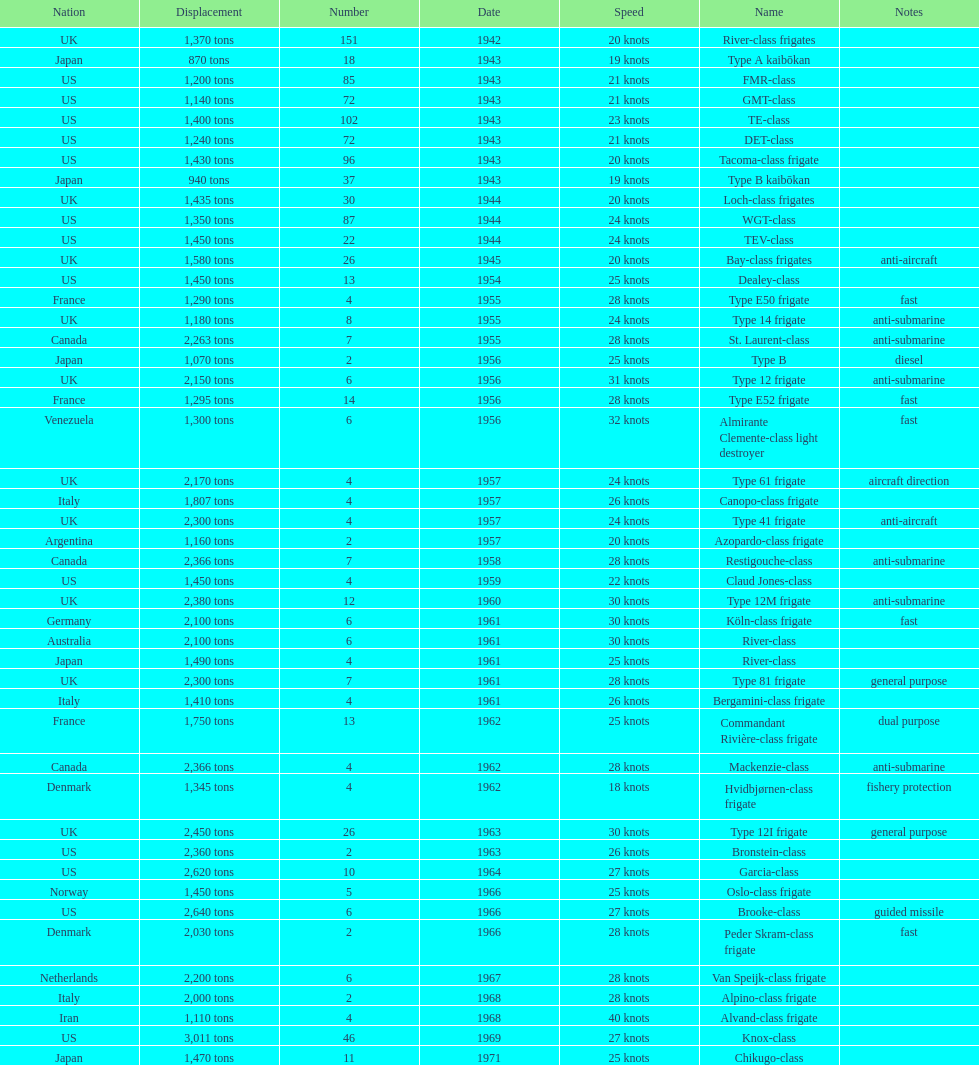What is the top speed? 40 knots. 